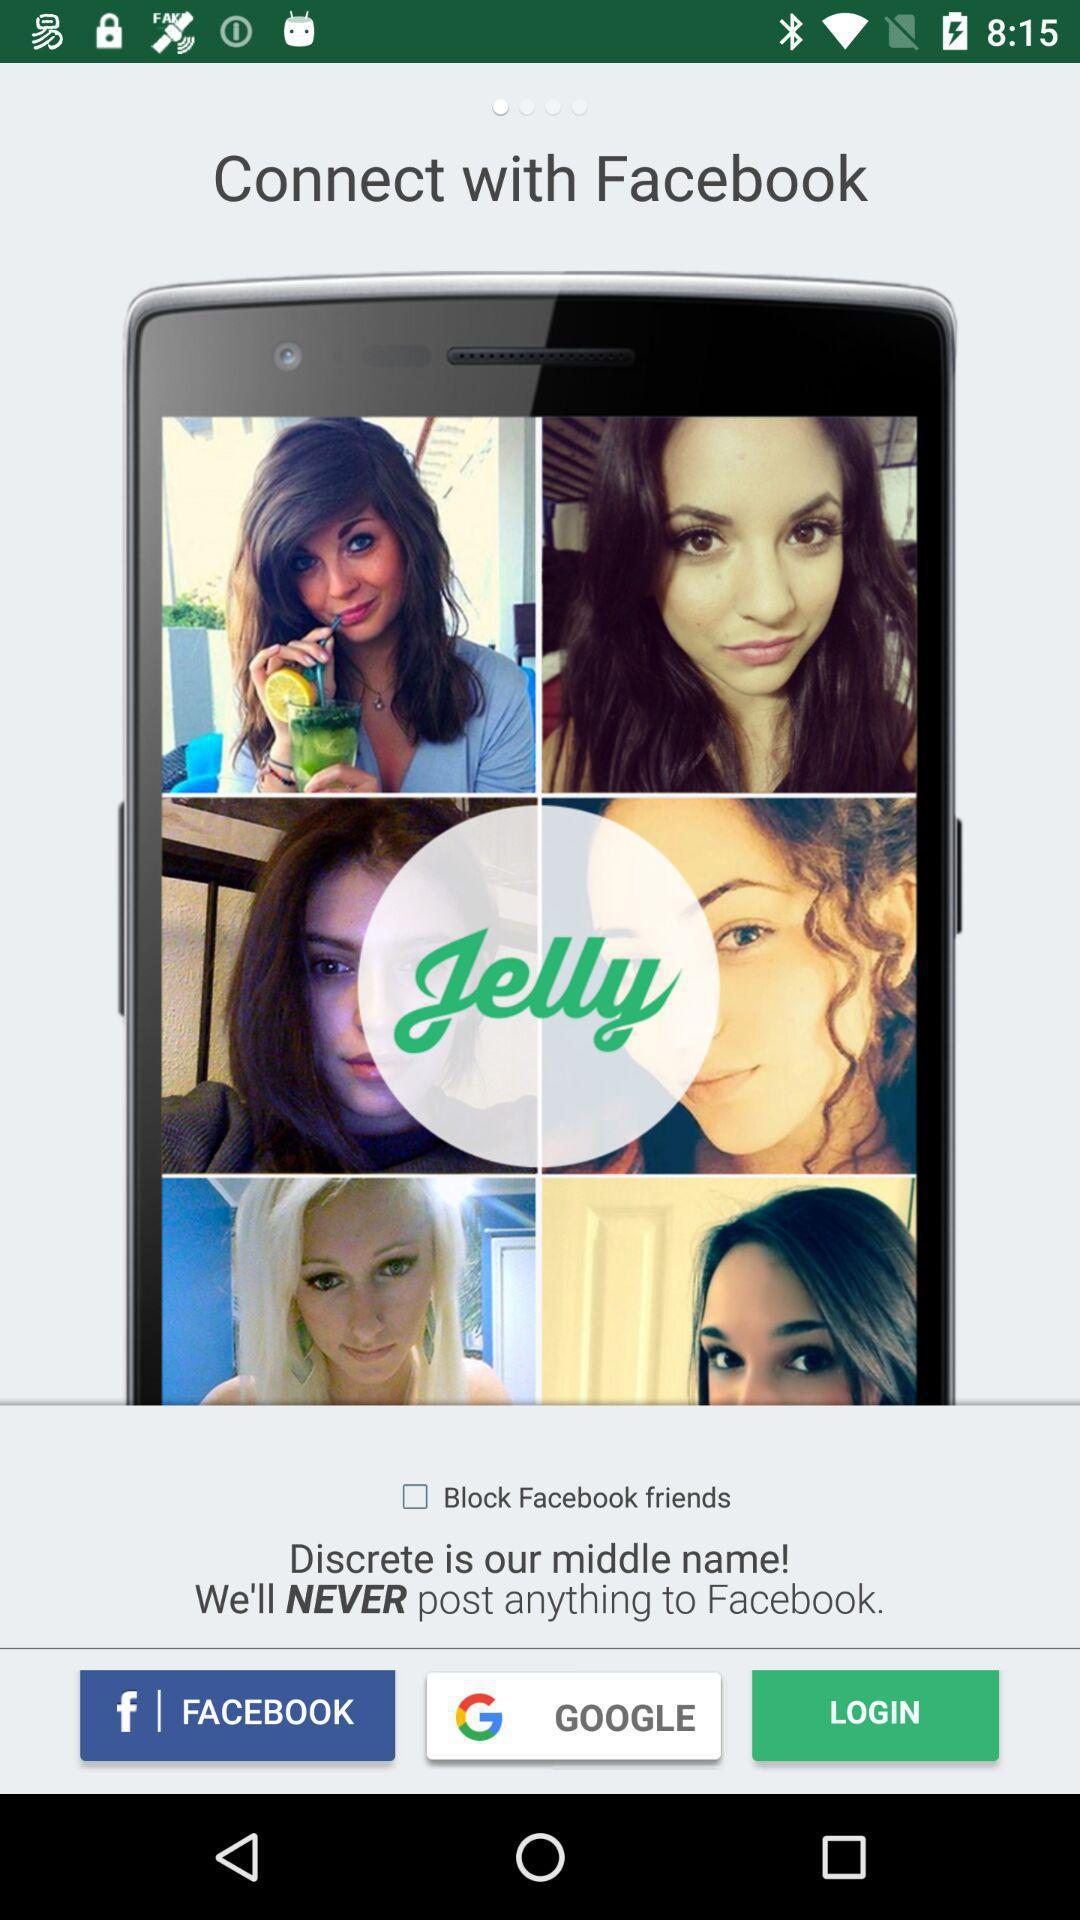What are the different login options? The login options are: "FACEBOOK" and "GOOGLE". 